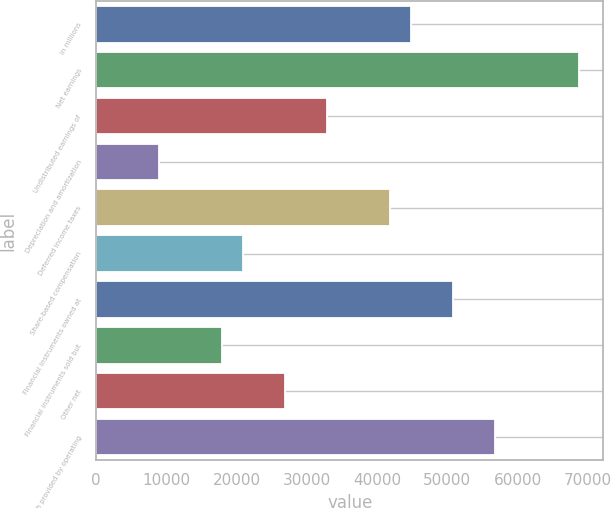Convert chart. <chart><loc_0><loc_0><loc_500><loc_500><bar_chart><fcel>in millions<fcel>Net earnings<fcel>Undistributed earnings of<fcel>Depreciation and amortization<fcel>Deferred income taxes<fcel>Share-based compensation<fcel>Financial instruments owned at<fcel>Financial instruments sold but<fcel>Other net<fcel>Net cash provided by operating<nl><fcel>44864.5<fcel>68791.7<fcel>32900.9<fcel>8973.7<fcel>41873.6<fcel>20937.3<fcel>50846.3<fcel>17946.4<fcel>26919.1<fcel>56828.1<nl></chart> 